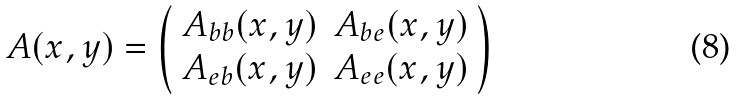Convert formula to latex. <formula><loc_0><loc_0><loc_500><loc_500>A ( x , y ) = \left ( \begin{array} { c c } A _ { b b } ( x , y ) & A _ { b e } ( x , y ) \\ A _ { e b } ( x , y ) & A _ { e e } ( x , y ) \end{array} \right )</formula> 